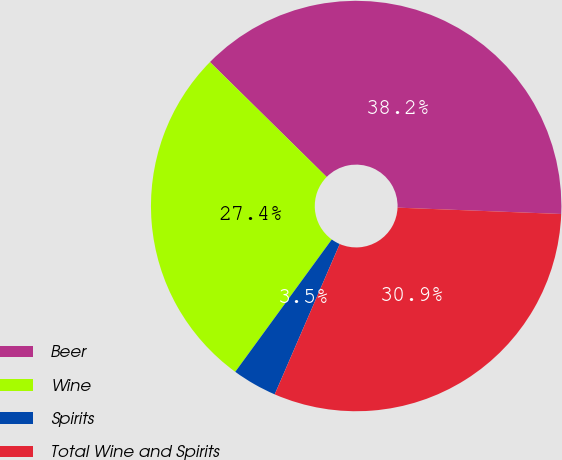Convert chart to OTSL. <chart><loc_0><loc_0><loc_500><loc_500><pie_chart><fcel>Beer<fcel>Wine<fcel>Spirits<fcel>Total Wine and Spirits<nl><fcel>38.24%<fcel>27.35%<fcel>3.53%<fcel>30.88%<nl></chart> 